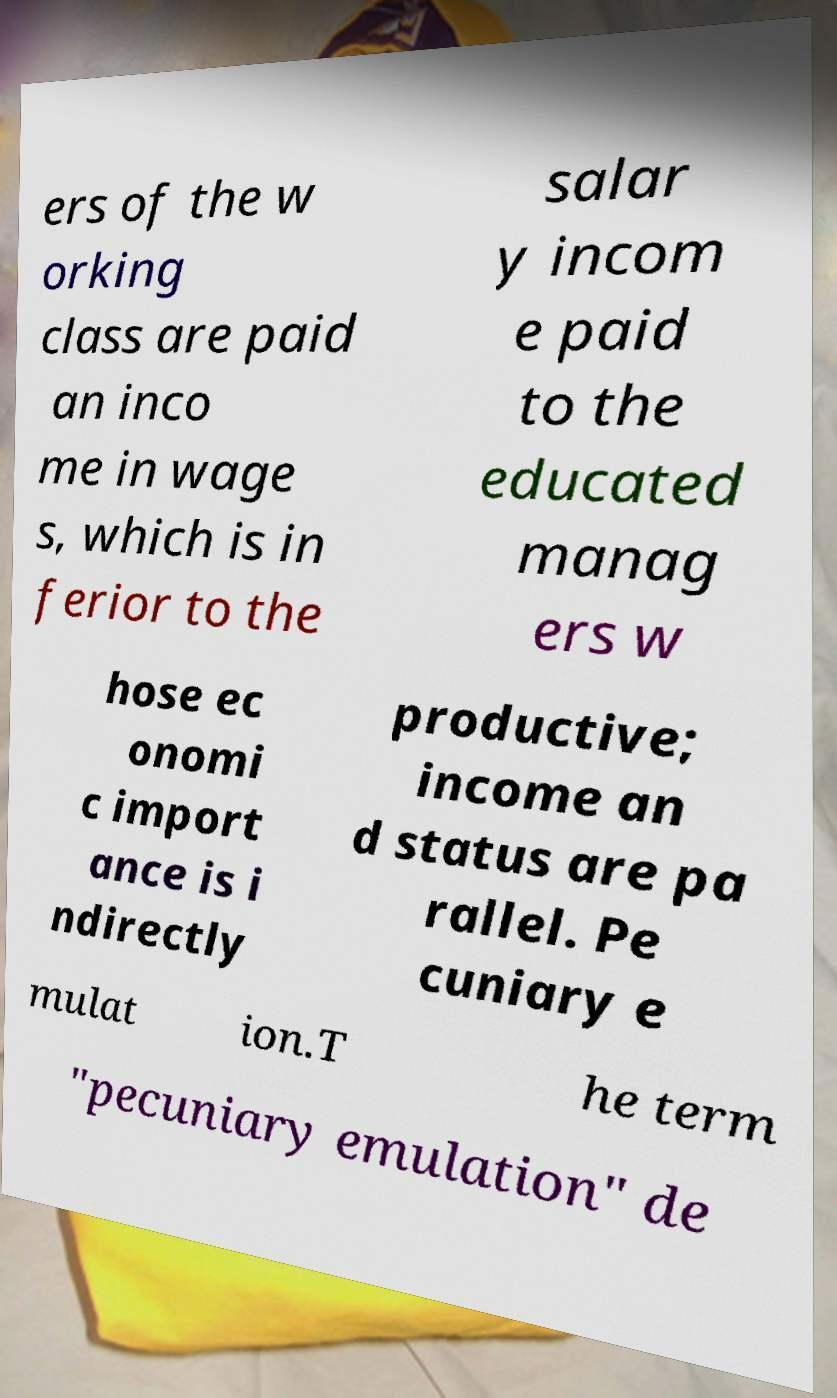Please read and relay the text visible in this image. What does it say? ers of the w orking class are paid an inco me in wage s, which is in ferior to the salar y incom e paid to the educated manag ers w hose ec onomi c import ance is i ndirectly productive; income an d status are pa rallel. Pe cuniary e mulat ion.T he term "pecuniary emulation" de 